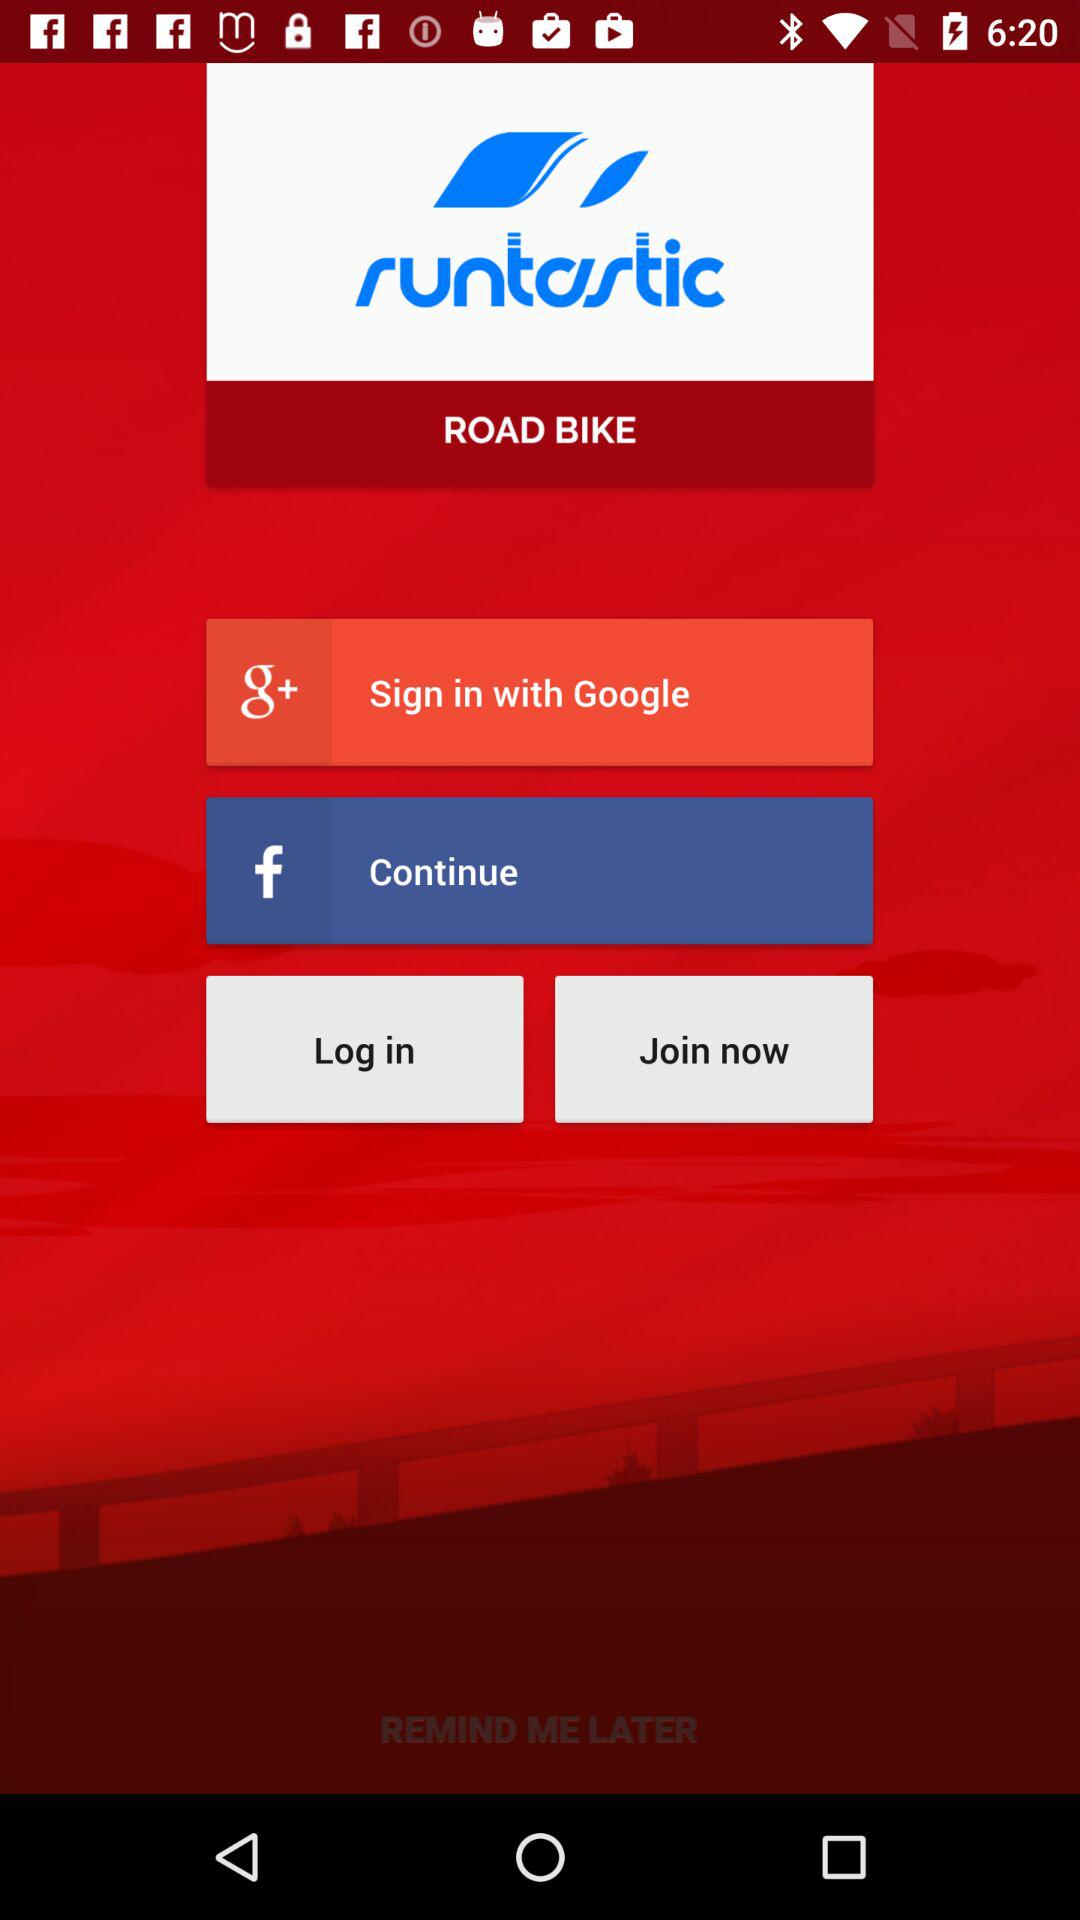What is the application name? The application name is "Runtastic Road Bike". 